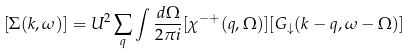<formula> <loc_0><loc_0><loc_500><loc_500>[ \Sigma ( { k } , \omega ) ] = U ^ { 2 } \sum _ { q } \int \frac { d \Omega } { 2 \pi i } [ \chi ^ { - + } ( { q } , \Omega ) ] [ G _ { \downarrow } ( { k - q } , \omega - \Omega ) ]</formula> 